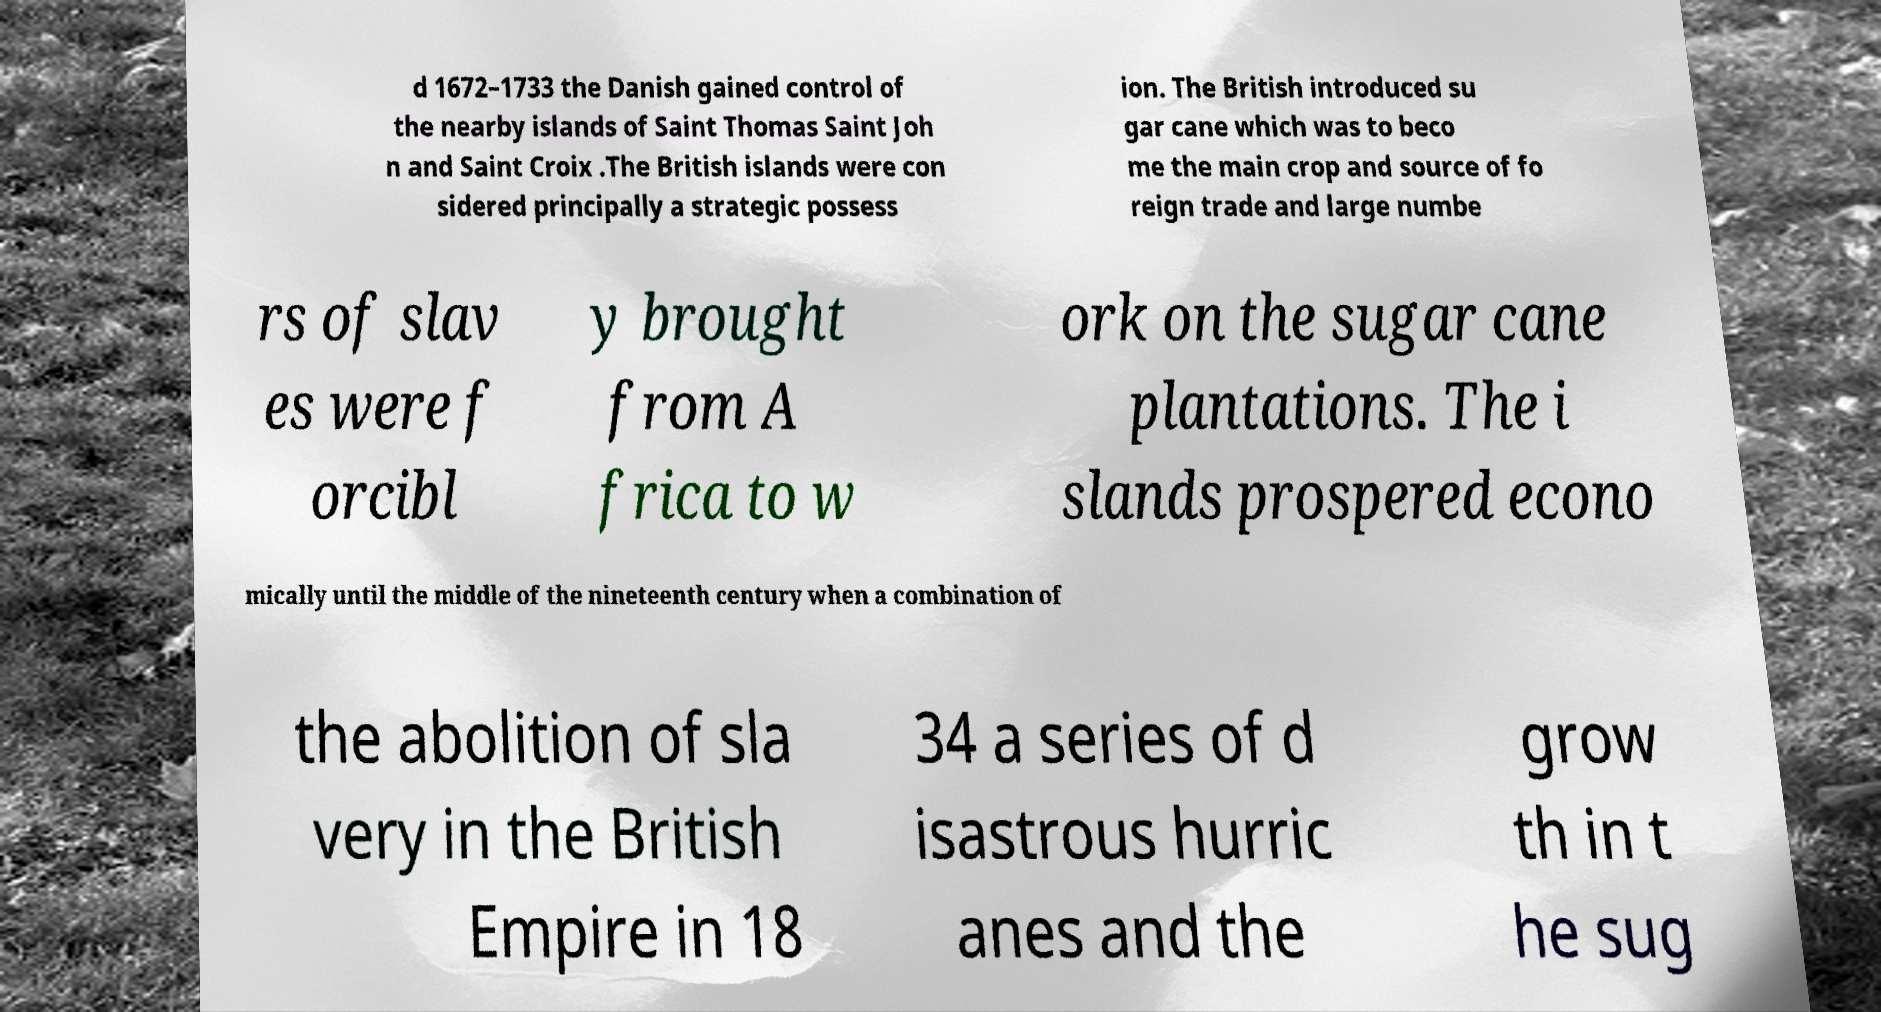For documentation purposes, I need the text within this image transcribed. Could you provide that? d 1672–1733 the Danish gained control of the nearby islands of Saint Thomas Saint Joh n and Saint Croix .The British islands were con sidered principally a strategic possess ion. The British introduced su gar cane which was to beco me the main crop and source of fo reign trade and large numbe rs of slav es were f orcibl y brought from A frica to w ork on the sugar cane plantations. The i slands prospered econo mically until the middle of the nineteenth century when a combination of the abolition of sla very in the British Empire in 18 34 a series of d isastrous hurric anes and the grow th in t he sug 